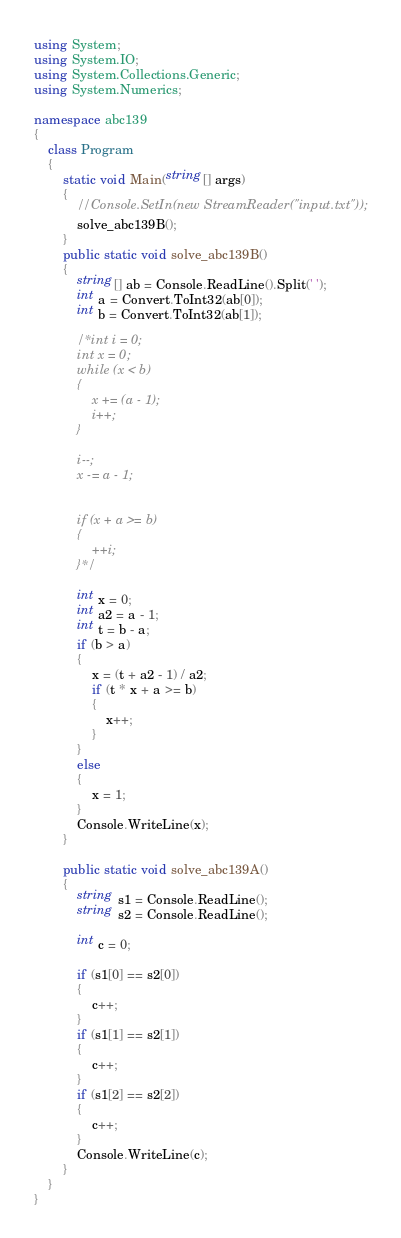Convert code to text. <code><loc_0><loc_0><loc_500><loc_500><_C#_>using System;
using System.IO;
using System.Collections.Generic;
using System.Numerics;

namespace abc139
{
    class Program
    {
        static void Main(string[] args)
        {
            //Console.SetIn(new StreamReader("input.txt"));
            solve_abc139B();
        }
        public static void solve_abc139B()
        {
            string[] ab = Console.ReadLine().Split(' ');
            int a = Convert.ToInt32(ab[0]);
            int b = Convert.ToInt32(ab[1]);

            /*int i = 0;
            int x = 0;
            while (x < b)
            {
                x += (a - 1);
                i++;
            }

            i--;
            x -= a - 1;


            if (x + a >= b)
            {
                ++i;
            }*/

            int x = 0;
            int a2 = a - 1;
            int t = b - a;
            if (b > a)
            {
                x = (t + a2 - 1) / a2;
                if (t * x + a >= b) 
                {
                    x++;
                }
            }
            else
            {
                x = 1;
            }
            Console.WriteLine(x);
        }

        public static void solve_abc139A()
        {
            string s1 = Console.ReadLine();
            string s2 = Console.ReadLine();

            int c = 0;

            if (s1[0] == s2[0])
            {
                c++;
            }
            if (s1[1] == s2[1])
            {
                c++;
            }
            if (s1[2] == s2[2])
            {
                c++;
            }
            Console.WriteLine(c);
        }
    }
}
</code> 